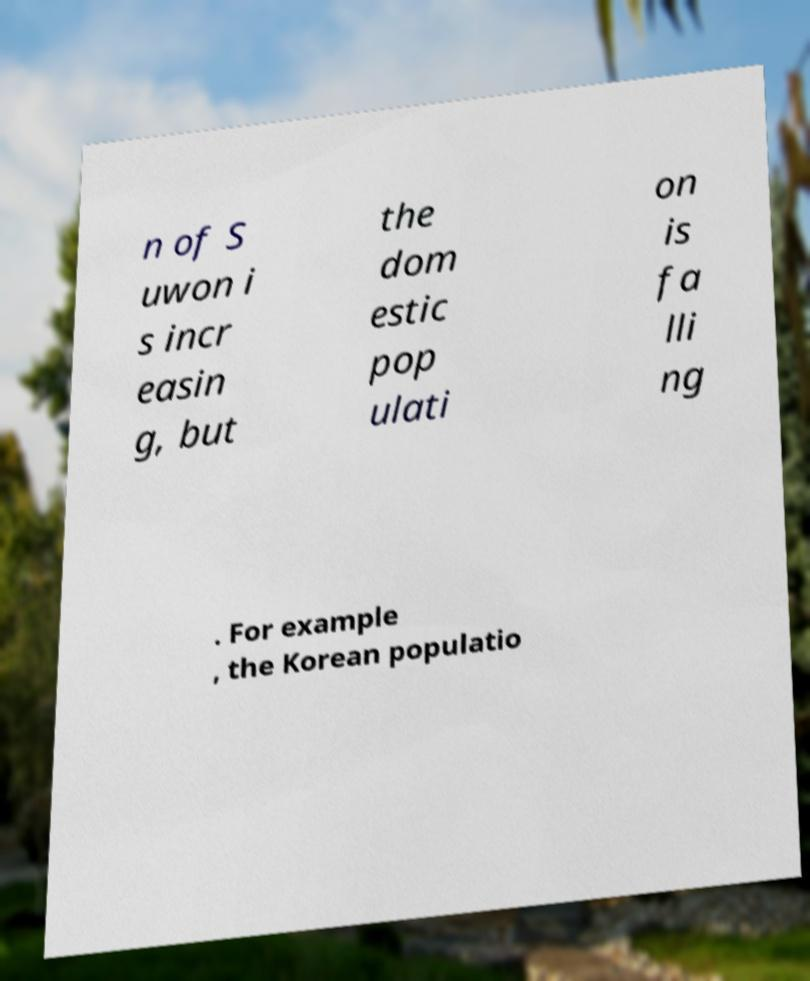Please identify and transcribe the text found in this image. n of S uwon i s incr easin g, but the dom estic pop ulati on is fa lli ng . For example , the Korean populatio 